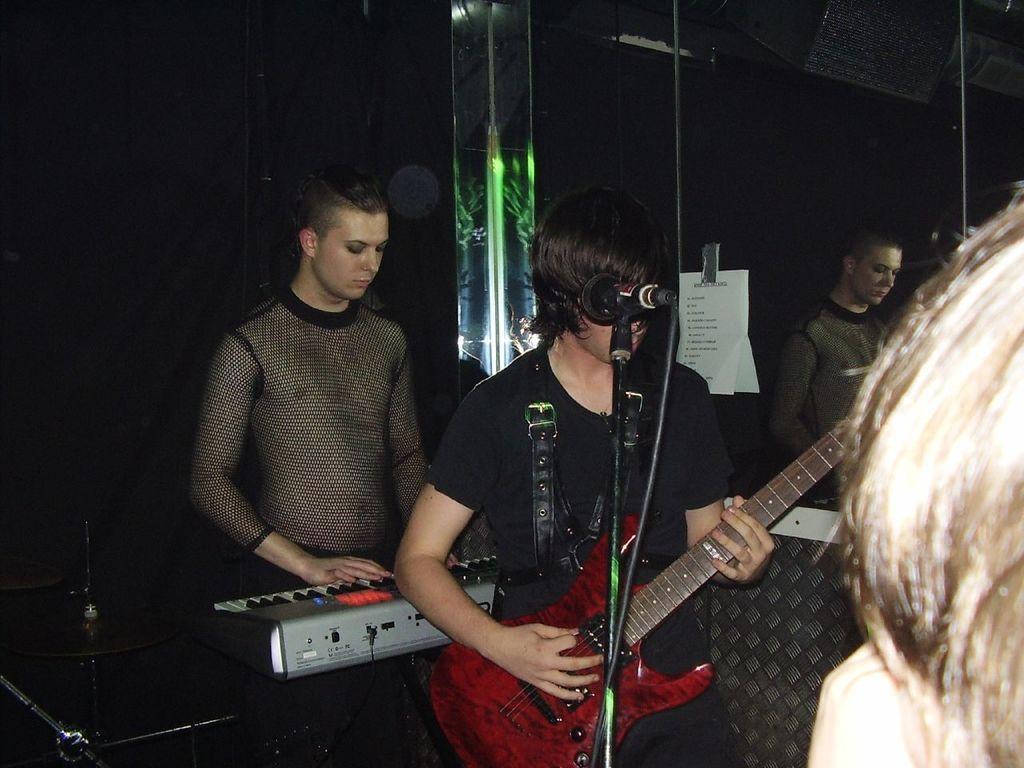Can you describe this image briefly? In this image a person is holding a guitar. Before him there is a mike stand. Behind him there is a person standing. He is playing the piano. Right side there is a person. Right side there is a mirror having the reflection of a person. A poster is attached to the mirror. Left side there is a musical instrument. 